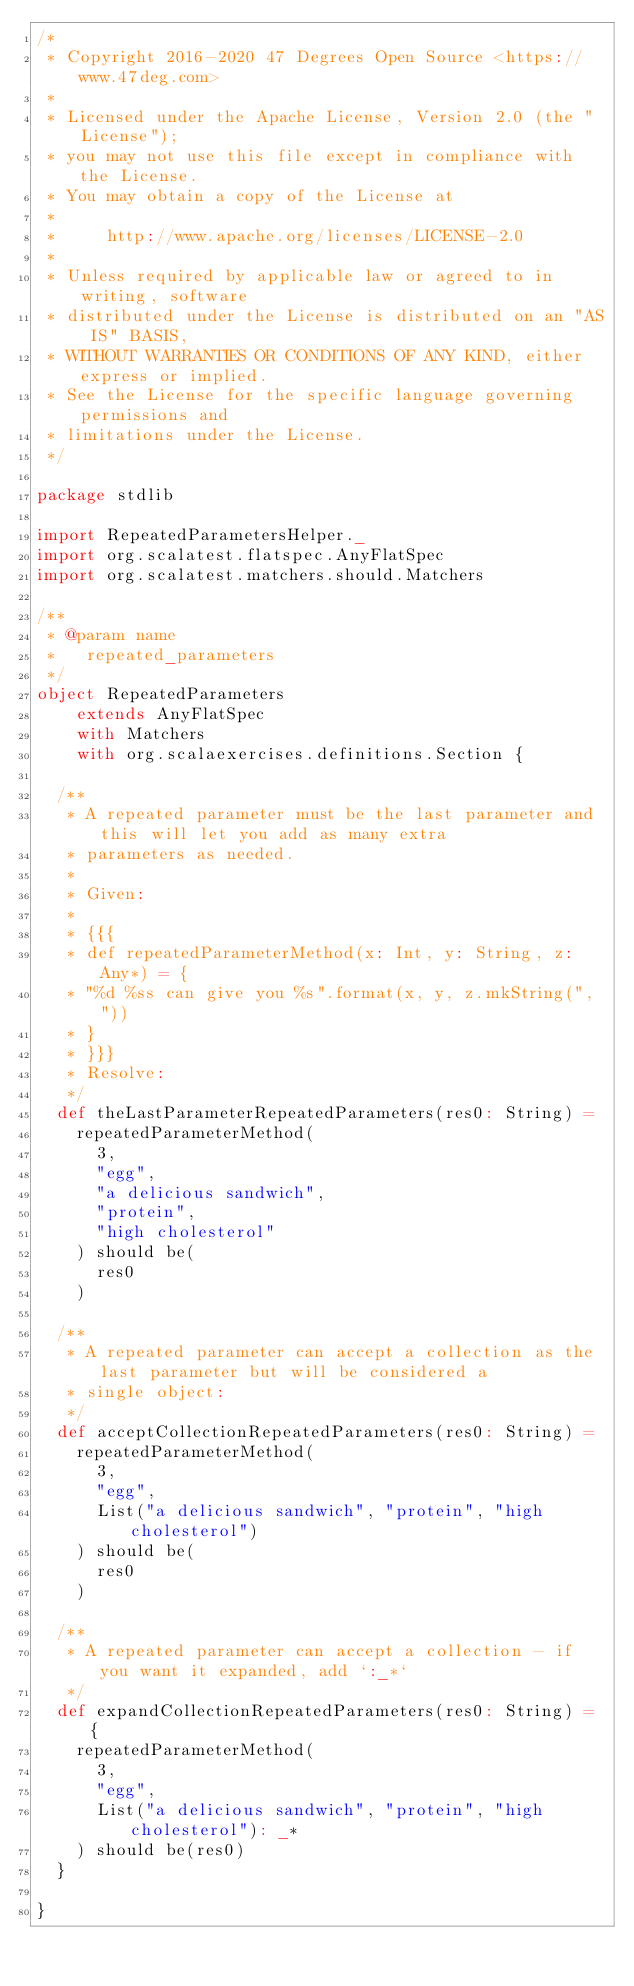<code> <loc_0><loc_0><loc_500><loc_500><_Scala_>/*
 * Copyright 2016-2020 47 Degrees Open Source <https://www.47deg.com>
 *
 * Licensed under the Apache License, Version 2.0 (the "License");
 * you may not use this file except in compliance with the License.
 * You may obtain a copy of the License at
 *
 *     http://www.apache.org/licenses/LICENSE-2.0
 *
 * Unless required by applicable law or agreed to in writing, software
 * distributed under the License is distributed on an "AS IS" BASIS,
 * WITHOUT WARRANTIES OR CONDITIONS OF ANY KIND, either express or implied.
 * See the License for the specific language governing permissions and
 * limitations under the License.
 */

package stdlib

import RepeatedParametersHelper._
import org.scalatest.flatspec.AnyFlatSpec
import org.scalatest.matchers.should.Matchers

/**
 * @param name
 *   repeated_parameters
 */
object RepeatedParameters
    extends AnyFlatSpec
    with Matchers
    with org.scalaexercises.definitions.Section {

  /**
   * A repeated parameter must be the last parameter and this will let you add as many extra
   * parameters as needed.
   *
   * Given:
   *
   * {{{
   * def repeatedParameterMethod(x: Int, y: String, z: Any*) = {
   * "%d %ss can give you %s".format(x, y, z.mkString(", "))
   * }
   * }}}
   * Resolve:
   */
  def theLastParameterRepeatedParameters(res0: String) =
    repeatedParameterMethod(
      3,
      "egg",
      "a delicious sandwich",
      "protein",
      "high cholesterol"
    ) should be(
      res0
    )

  /**
   * A repeated parameter can accept a collection as the last parameter but will be considered a
   * single object:
   */
  def acceptCollectionRepeatedParameters(res0: String) =
    repeatedParameterMethod(
      3,
      "egg",
      List("a delicious sandwich", "protein", "high cholesterol")
    ) should be(
      res0
    )

  /**
   * A repeated parameter can accept a collection - if you want it expanded, add `:_*`
   */
  def expandCollectionRepeatedParameters(res0: String) = {
    repeatedParameterMethod(
      3,
      "egg",
      List("a delicious sandwich", "protein", "high cholesterol"): _*
    ) should be(res0)
  }

}
</code> 